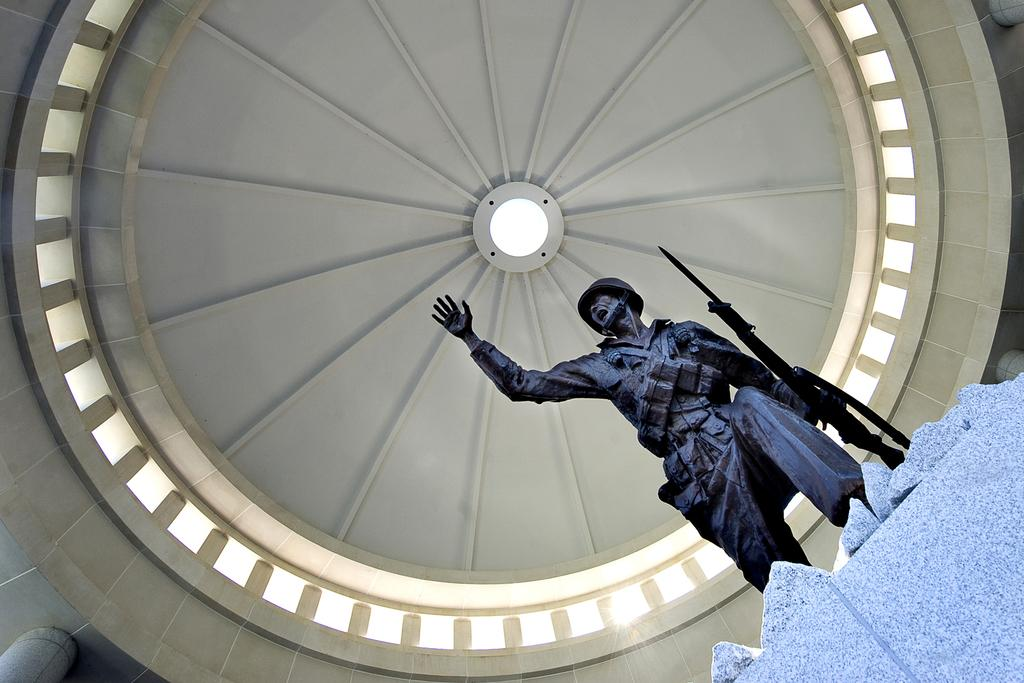What is the main subject of the image? There is a statue of a person in the image. What is the person in the statue holding? The person is holding a gun in their hands. What can be seen at the top of the image? The top of the image features a roof. What type of cloth is draped over the dinner table in the image? There is no dinner table or cloth present in the image; it features a statue of a person holding a gun and a roof at the top. 